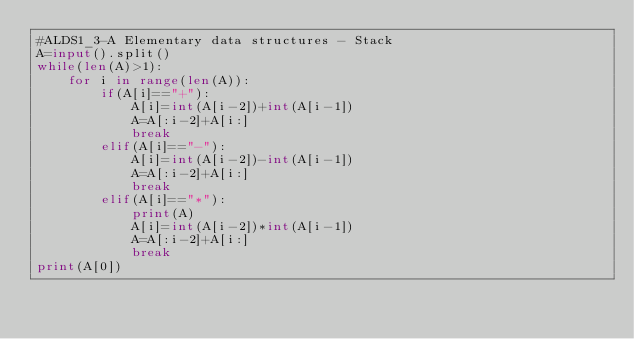<code> <loc_0><loc_0><loc_500><loc_500><_Python_>#ALDS1_3-A Elementary data structures - Stack
A=input().split()
while(len(A)>1):
    for i in range(len(A)):
        if(A[i]=="+"):
            A[i]=int(A[i-2])+int(A[i-1])
            A=A[:i-2]+A[i:]
            break
        elif(A[i]=="-"):
            A[i]=int(A[i-2])-int(A[i-1])
            A=A[:i-2]+A[i:]
            break
        elif(A[i]=="*"):
            print(A)
            A[i]=int(A[i-2])*int(A[i-1])
            A=A[:i-2]+A[i:]
            break
print(A[0])</code> 